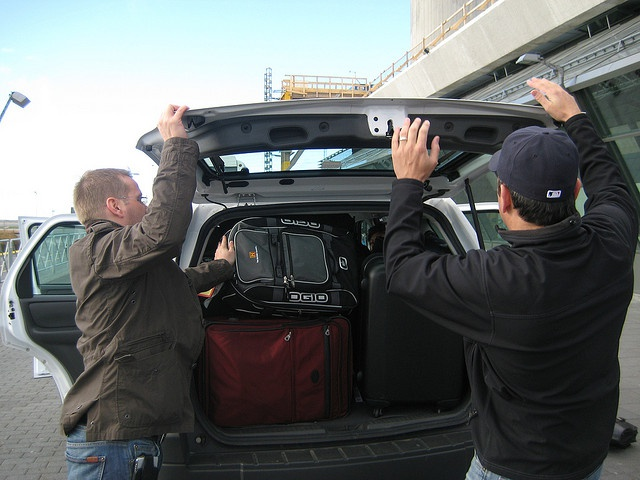Describe the objects in this image and their specific colors. I can see car in lightblue, black, gray, darkgray, and purple tones, people in lightblue, black, gray, and tan tones, people in lightblue, black, gray, and darkgray tones, suitcase in lightblue, black, maroon, and gray tones, and backpack in lightblue, black, gray, purple, and darkgray tones in this image. 